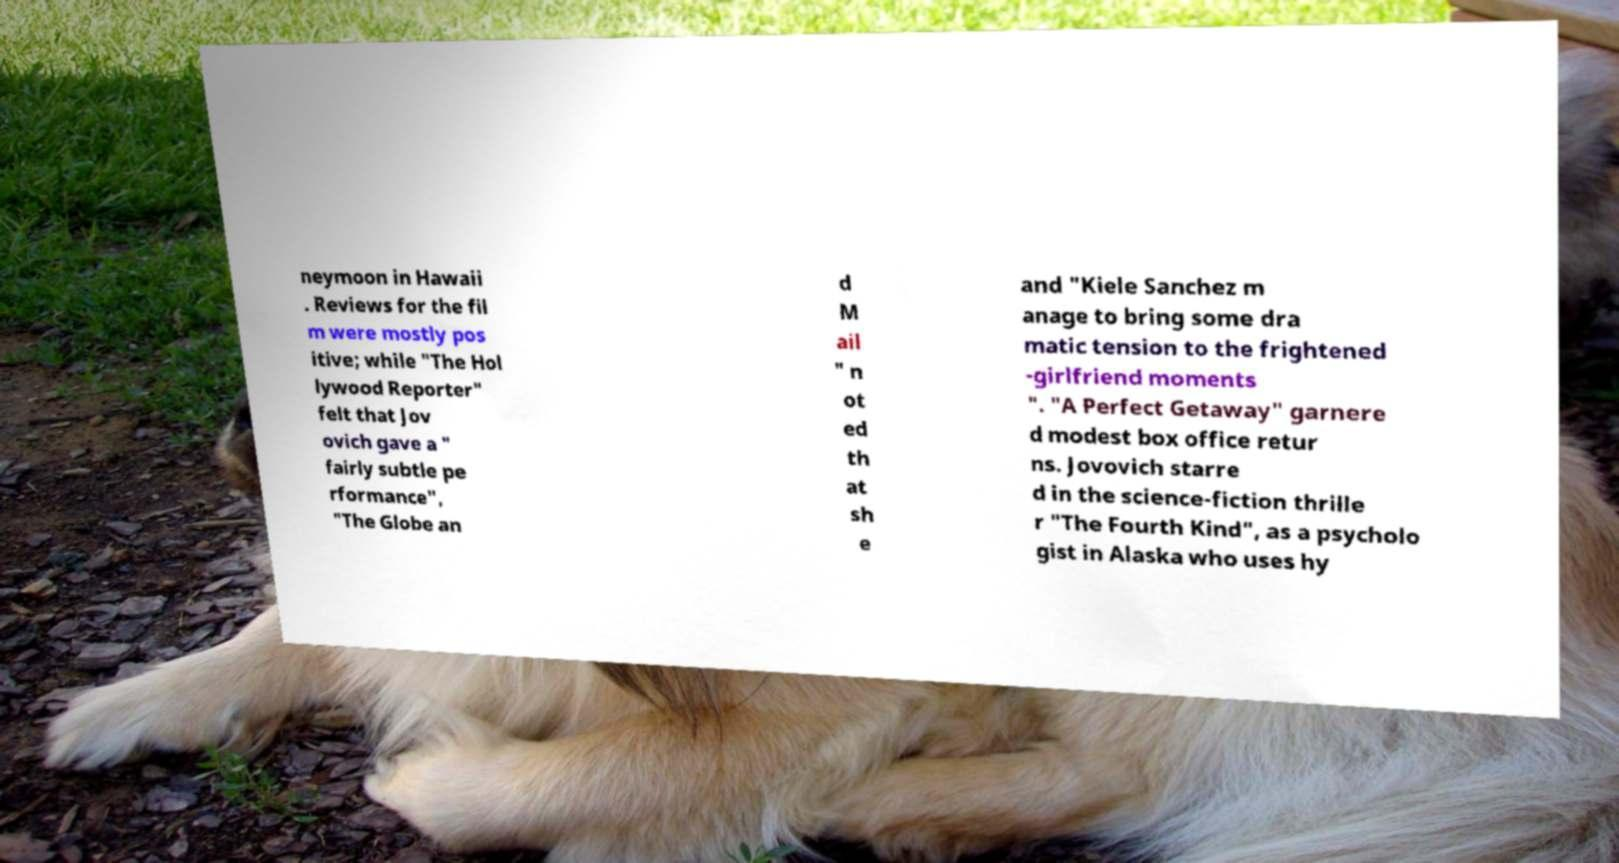What messages or text are displayed in this image? I need them in a readable, typed format. neymoon in Hawaii . Reviews for the fil m were mostly pos itive; while "The Hol lywood Reporter" felt that Jov ovich gave a " fairly subtle pe rformance", "The Globe an d M ail " n ot ed th at sh e and "Kiele Sanchez m anage to bring some dra matic tension to the frightened -girlfriend moments ". "A Perfect Getaway" garnere d modest box office retur ns. Jovovich starre d in the science-fiction thrille r "The Fourth Kind", as a psycholo gist in Alaska who uses hy 